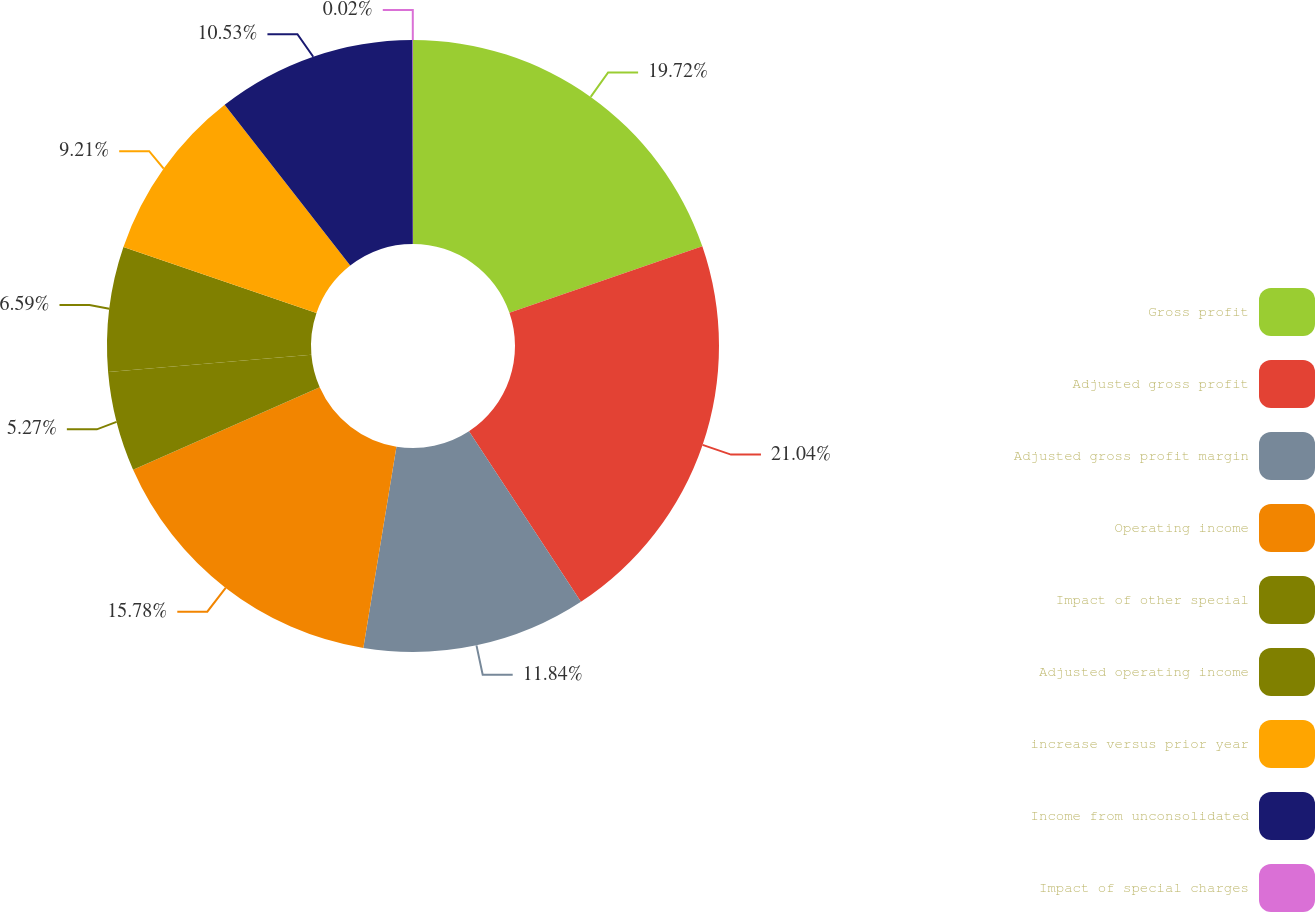<chart> <loc_0><loc_0><loc_500><loc_500><pie_chart><fcel>Gross profit<fcel>Adjusted gross profit<fcel>Adjusted gross profit margin<fcel>Operating income<fcel>Impact of other special<fcel>Adjusted operating income<fcel>increase versus prior year<fcel>Income from unconsolidated<fcel>Impact of special charges<nl><fcel>19.72%<fcel>21.03%<fcel>11.84%<fcel>15.78%<fcel>5.27%<fcel>6.59%<fcel>9.21%<fcel>10.53%<fcel>0.02%<nl></chart> 